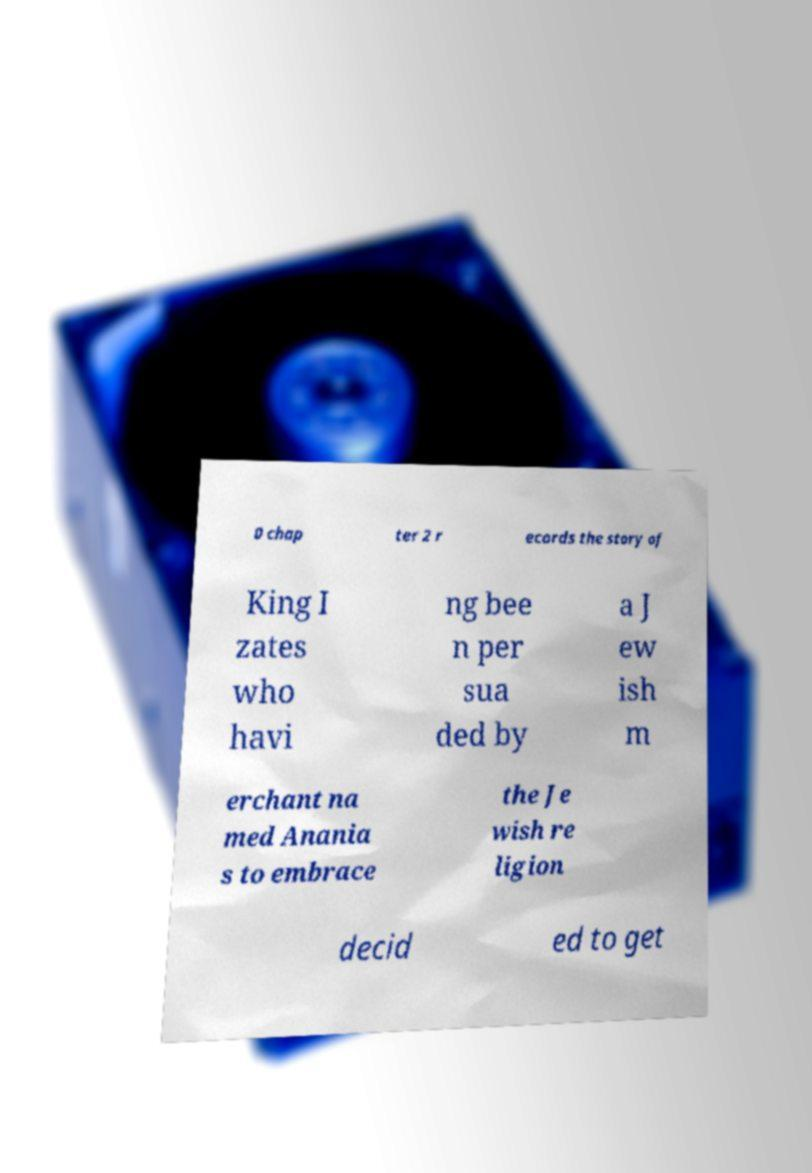Could you extract and type out the text from this image? 0 chap ter 2 r ecords the story of King I zates who havi ng bee n per sua ded by a J ew ish m erchant na med Anania s to embrace the Je wish re ligion decid ed to get 